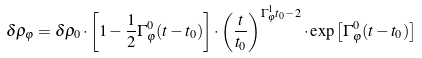Convert formula to latex. <formula><loc_0><loc_0><loc_500><loc_500>\delta \rho _ { \varphi } = \delta \rho _ { 0 } \cdot \left [ 1 - \frac { 1 } { 2 } \Gamma _ { \varphi } ^ { 0 } ( t - t _ { 0 } ) \right ] \cdot \left ( \frac { t } { t _ { 0 } } \right ) ^ { \Gamma _ { \varphi } ^ { 1 } t _ { 0 } - 2 } \cdot \exp \left [ \Gamma _ { \varphi } ^ { 0 } ( t - t _ { 0 } ) \right ]</formula> 